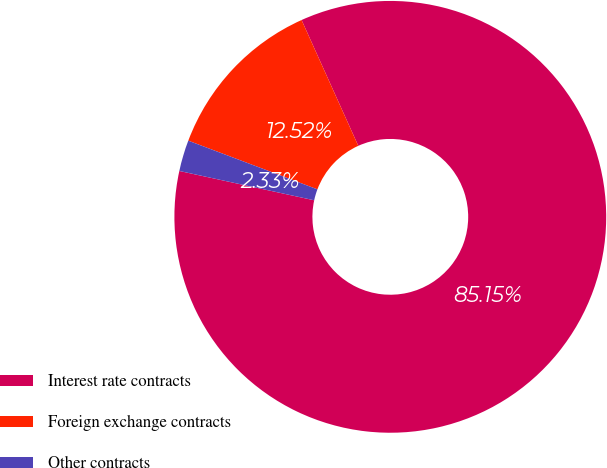Convert chart. <chart><loc_0><loc_0><loc_500><loc_500><pie_chart><fcel>Interest rate contracts<fcel>Foreign exchange contracts<fcel>Other contracts<nl><fcel>85.14%<fcel>12.52%<fcel>2.33%<nl></chart> 